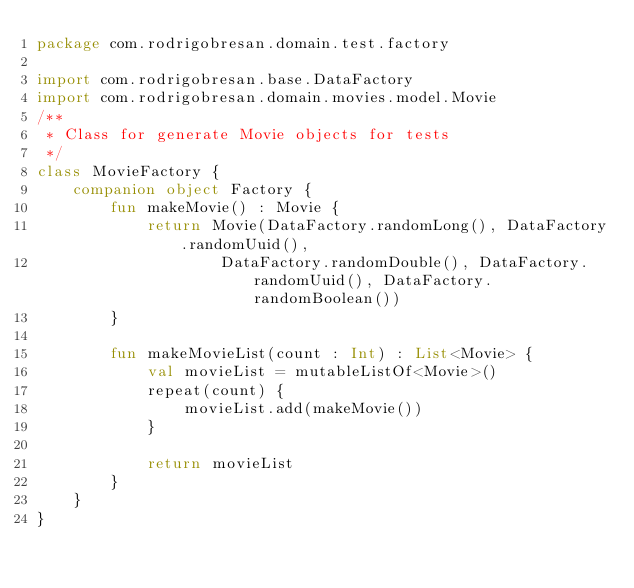Convert code to text. <code><loc_0><loc_0><loc_500><loc_500><_Kotlin_>package com.rodrigobresan.domain.test.factory

import com.rodrigobresan.base.DataFactory
import com.rodrigobresan.domain.movies.model.Movie
/**
 * Class for generate Movie objects for tests
 */
class MovieFactory {
    companion object Factory {
        fun makeMovie() : Movie {
            return Movie(DataFactory.randomLong(), DataFactory.randomUuid(),
                    DataFactory.randomDouble(), DataFactory.randomUuid(), DataFactory.randomBoolean())
        }

        fun makeMovieList(count : Int) : List<Movie> {
            val movieList = mutableListOf<Movie>()
            repeat(count) {
                movieList.add(makeMovie())
            }

            return movieList
        }
    }
}</code> 